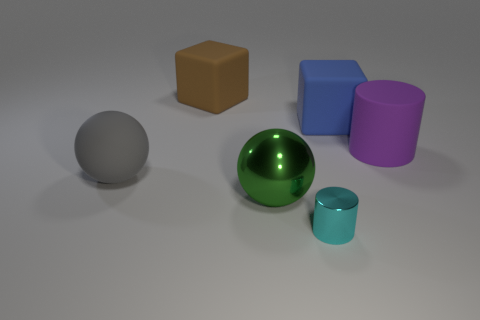Are there any purple matte objects of the same size as the purple cylinder?
Make the answer very short. No. Are there fewer big purple rubber cylinders in front of the large shiny ball than red shiny cylinders?
Provide a succinct answer. No. Are there fewer large matte cylinders to the left of the brown matte block than cylinders behind the big gray object?
Give a very brief answer. Yes. How many blocks are either big purple rubber objects or big brown objects?
Your answer should be very brief. 1. Is the material of the cylinder that is on the left side of the large cylinder the same as the big sphere in front of the gray ball?
Your answer should be compact. Yes. What shape is the purple matte thing that is the same size as the gray rubber ball?
Your answer should be very brief. Cylinder. How many other things are there of the same color as the tiny shiny cylinder?
Make the answer very short. 0. What number of green objects are either large rubber objects or big matte blocks?
Offer a very short reply. 0. There is a large matte object left of the brown thing; is it the same shape as the metal object left of the cyan metal thing?
Make the answer very short. Yes. What number of other objects are there of the same material as the green thing?
Provide a succinct answer. 1. 